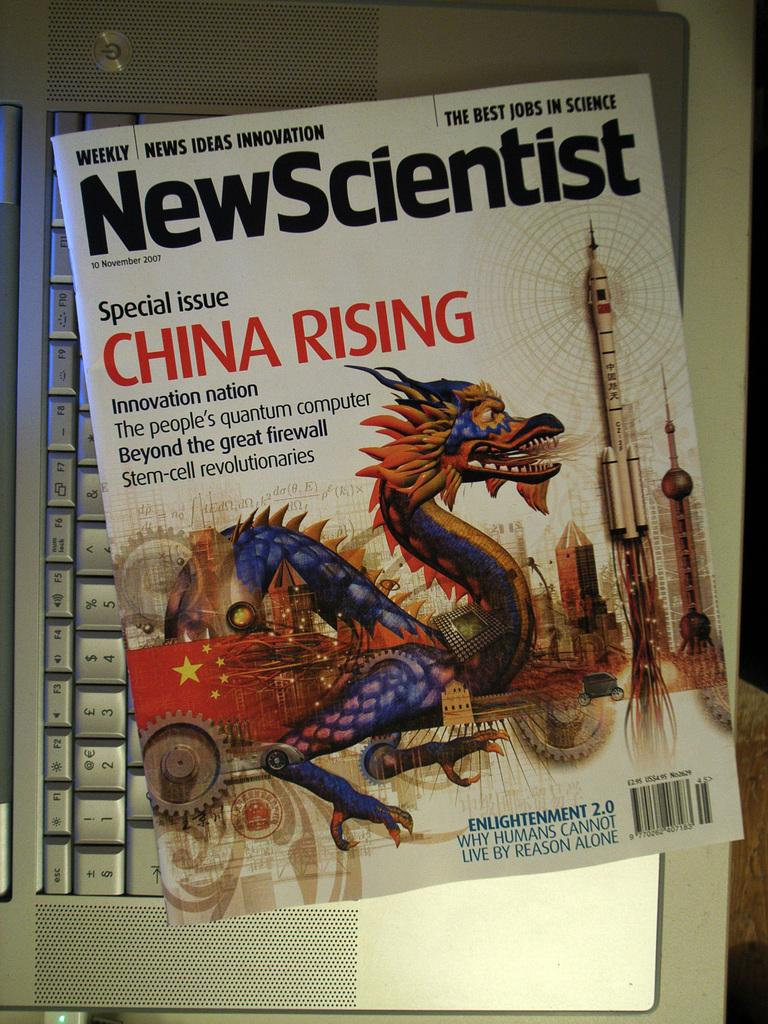<image>
Provide a brief description of the given image. A New Scientist Magazine about China Rising sits on a laptop keyboard. 